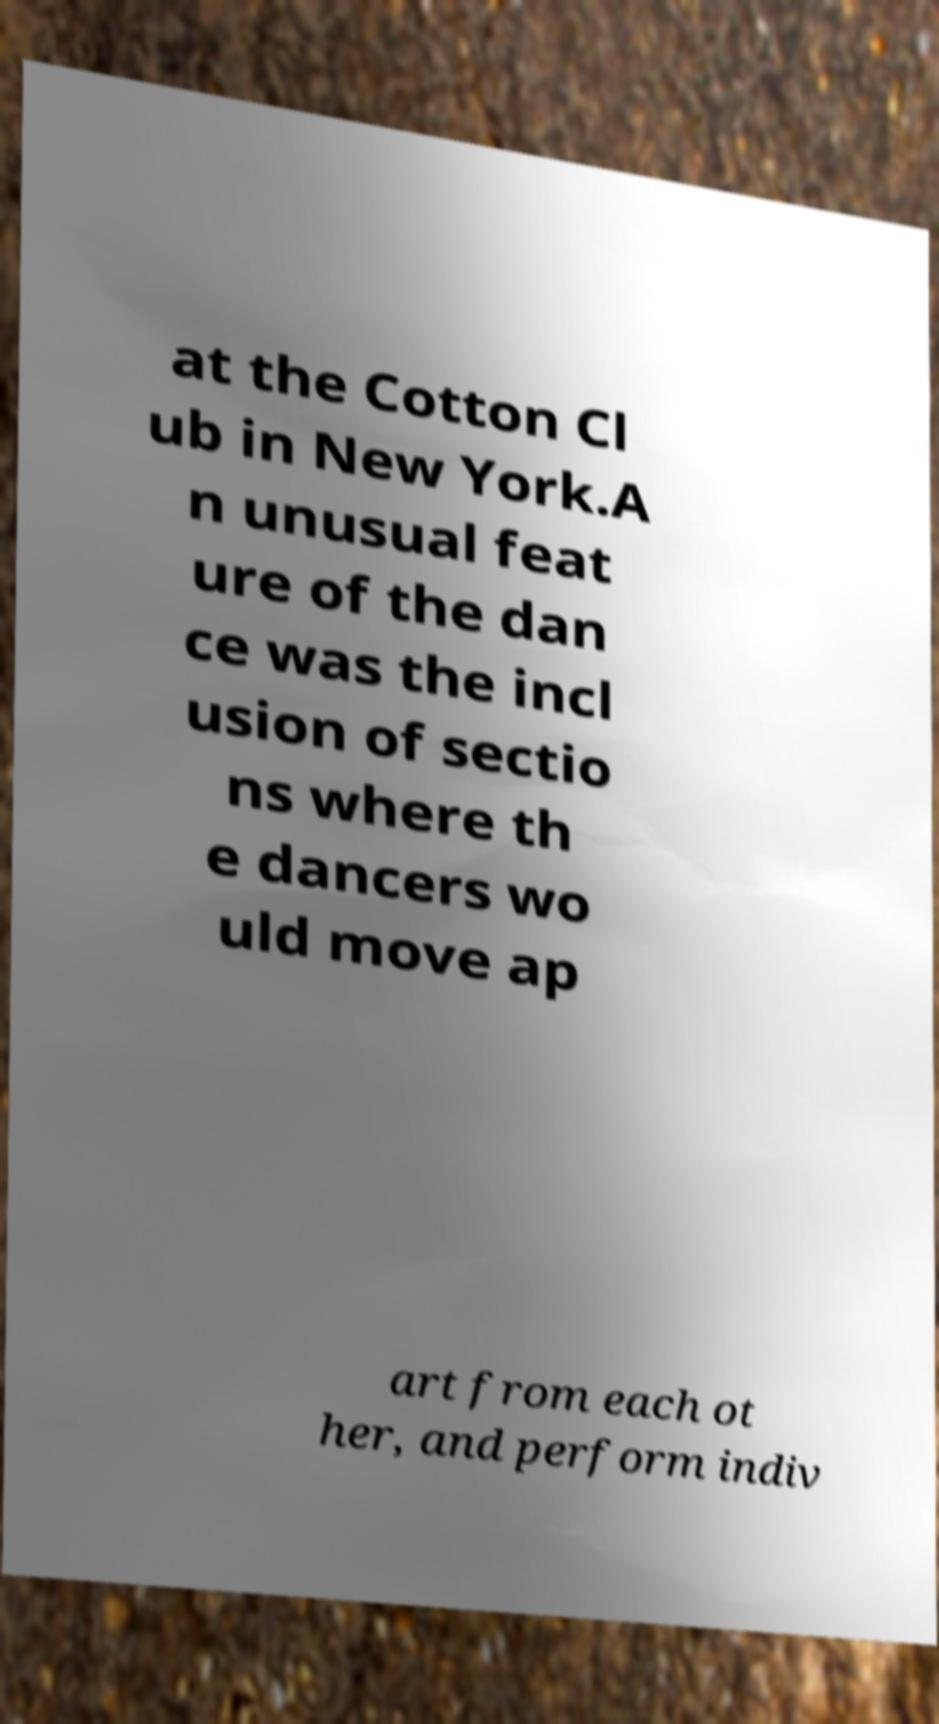There's text embedded in this image that I need extracted. Can you transcribe it verbatim? at the Cotton Cl ub in New York.A n unusual feat ure of the dan ce was the incl usion of sectio ns where th e dancers wo uld move ap art from each ot her, and perform indiv 